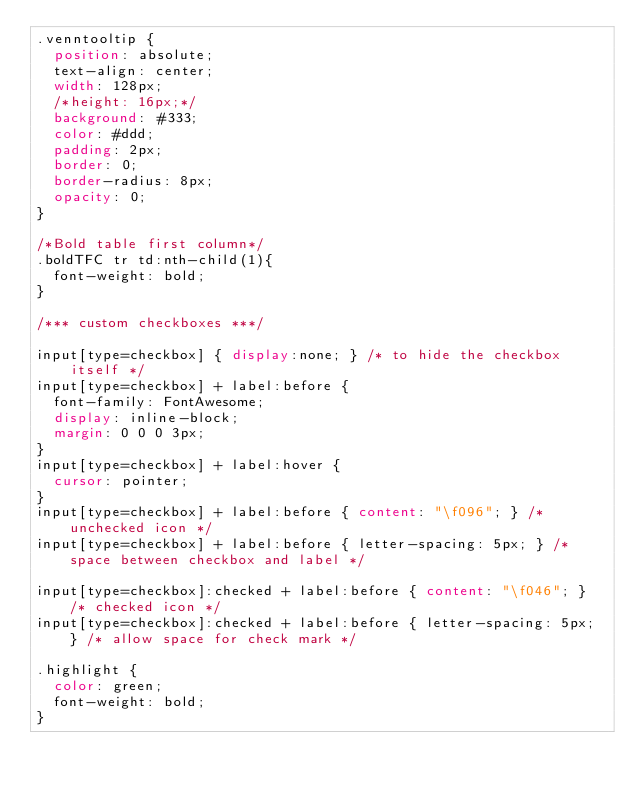<code> <loc_0><loc_0><loc_500><loc_500><_CSS_>.venntooltip {
  position: absolute;
  text-align: center;
  width: 128px;
  /*height: 16px;*/
  background: #333;
  color: #ddd;
  padding: 2px;
  border: 0;
  border-radius: 8px;
  opacity: 0;
}

/*Bold table first column*/
.boldTFC tr td:nth-child(1){
  font-weight: bold;
}

/*** custom checkboxes ***/

input[type=checkbox] { display:none; } /* to hide the checkbox itself */
input[type=checkbox] + label:before {
  font-family: FontAwesome;
  display: inline-block;
  margin: 0 0 0 3px;
}
input[type=checkbox] + label:hover {
  cursor: pointer;
}
input[type=checkbox] + label:before { content: "\f096"; } /* unchecked icon */
input[type=checkbox] + label:before { letter-spacing: 5px; } /* space between checkbox and label */

input[type=checkbox]:checked + label:before { content: "\f046"; } /* checked icon */
input[type=checkbox]:checked + label:before { letter-spacing: 5px; } /* allow space for check mark */

.highlight {
  color: green;
  font-weight: bold;
}</code> 